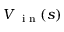Convert formula to latex. <formula><loc_0><loc_0><loc_500><loc_500>V _ { i n } ( s )</formula> 